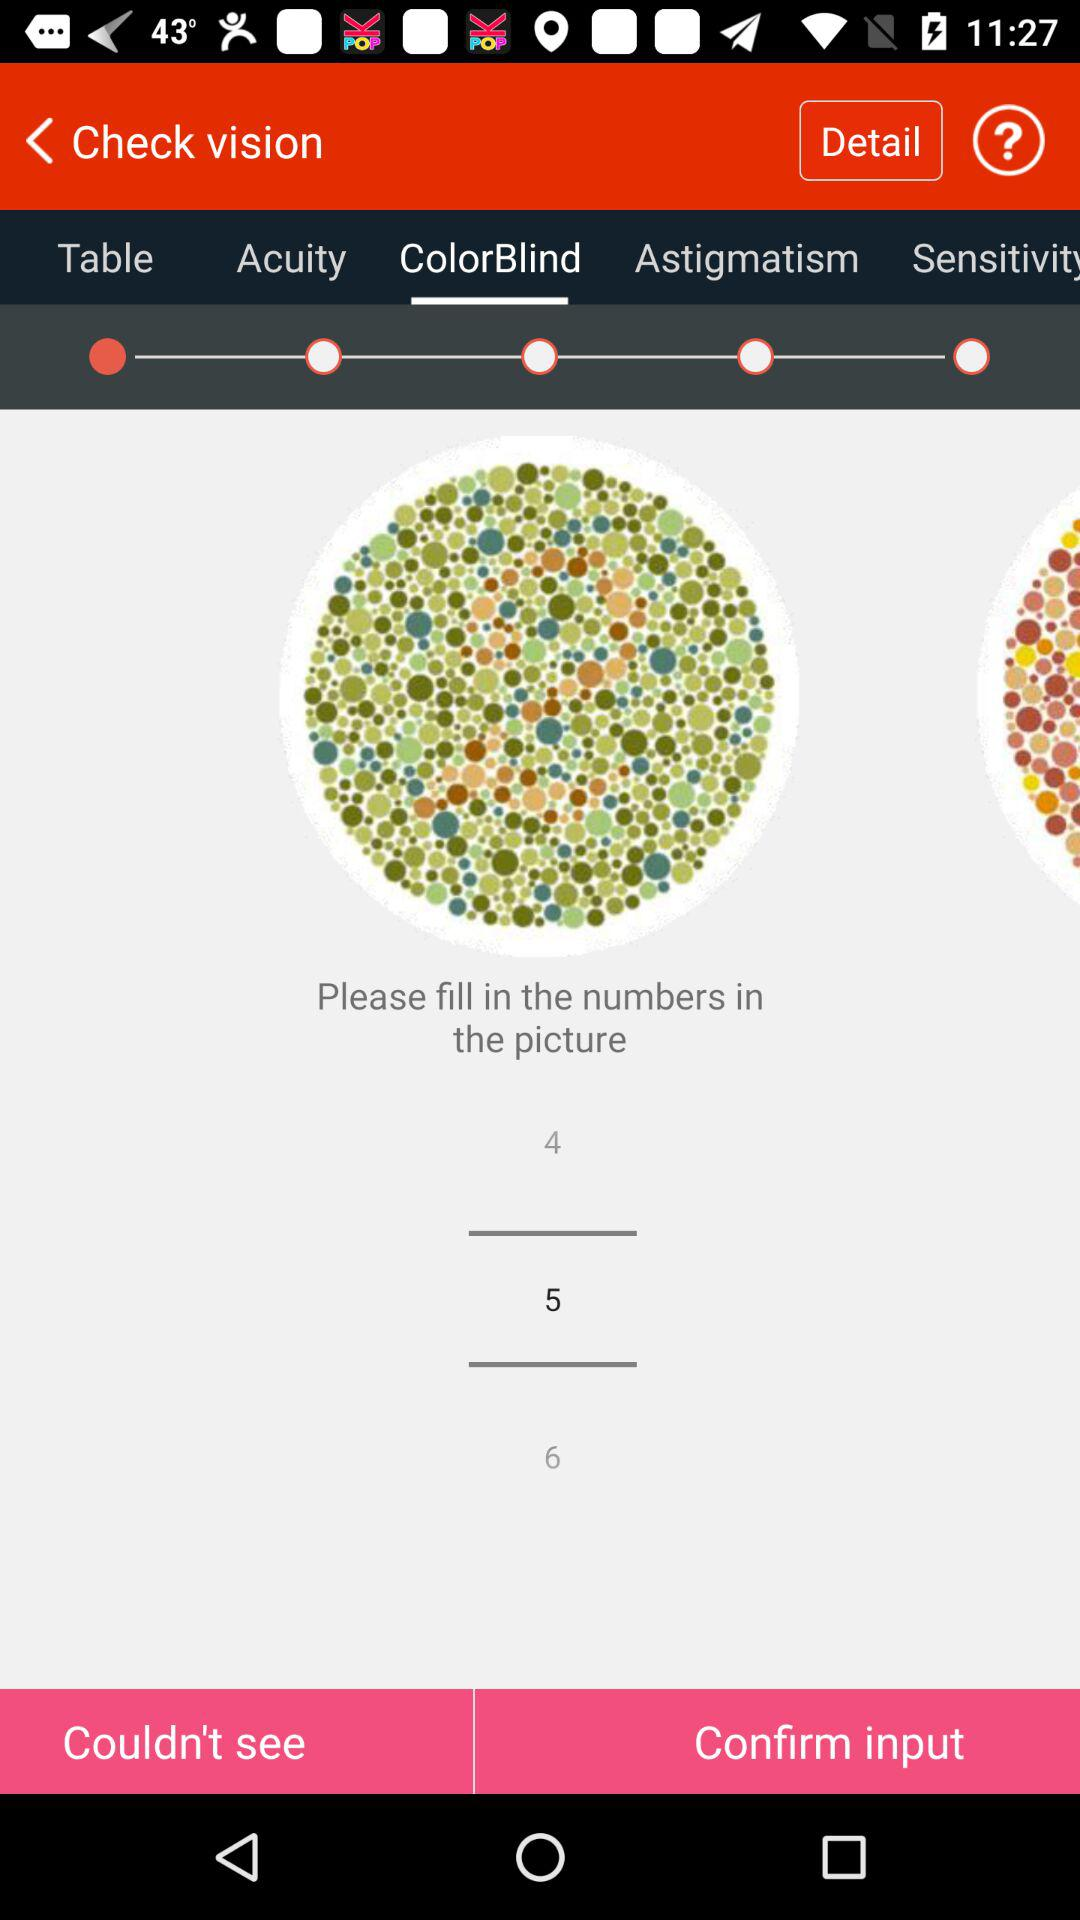Which tab of check vision is selected? The selected tab is "ColorBlind". 